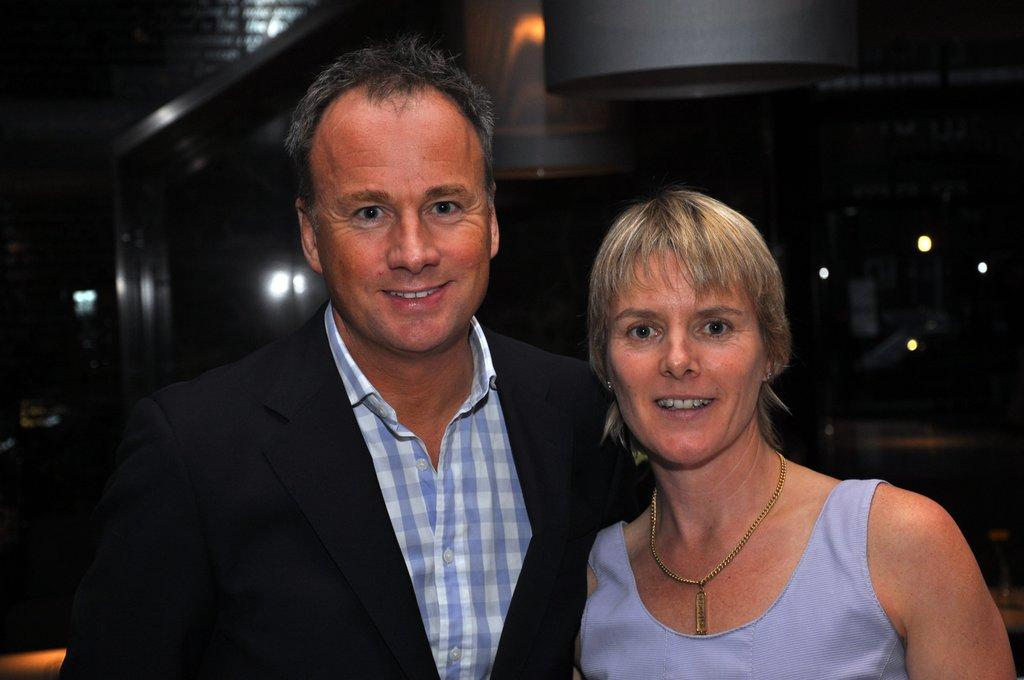Who is in the foreground of the picture? There is a couple in the foreground of the picture. What are the couple doing in the image? The couple is standing and smiling. What can be seen in the background of the image? There are lights visible in the background of the image. How would you describe the overall lighting in the image? The background is dark, which contrasts with the lights in the background. How many sticks are being used by the couple in the image? There are no sticks visible in the image; the couple is simply standing and smiling. What type of spark can be seen between the couple in the image? There is no spark visible between the couple in the image; they are just standing and smiling. 